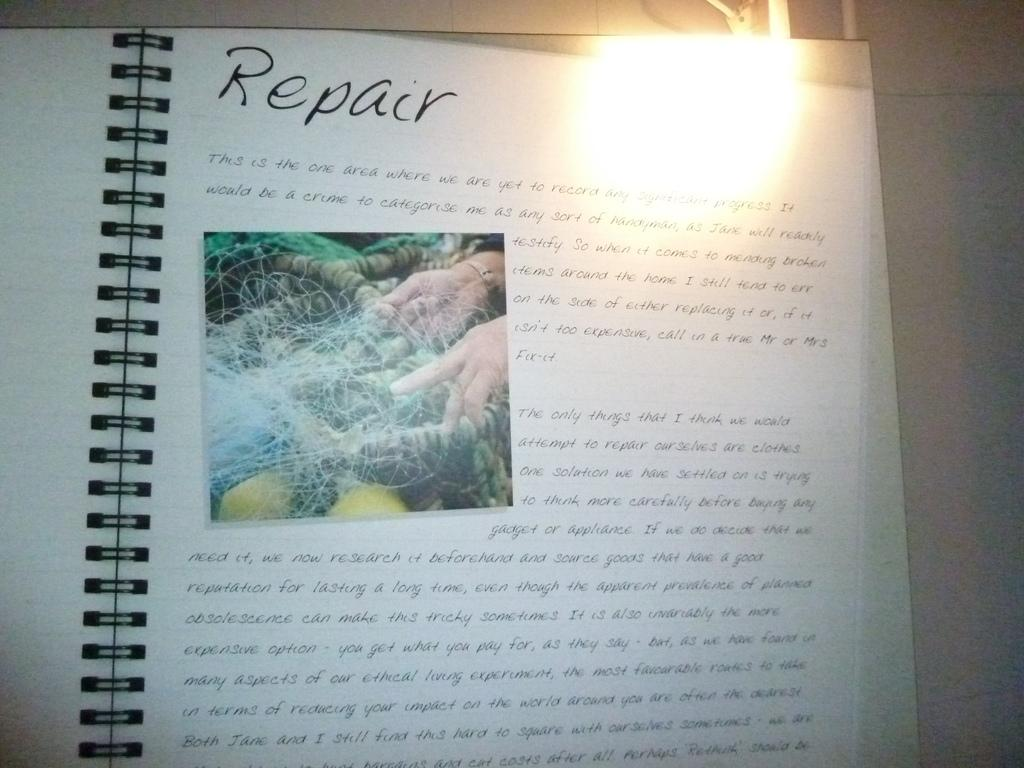Provide a one-sentence caption for the provided image. an open book to the word Repair has an overexposed corner. 